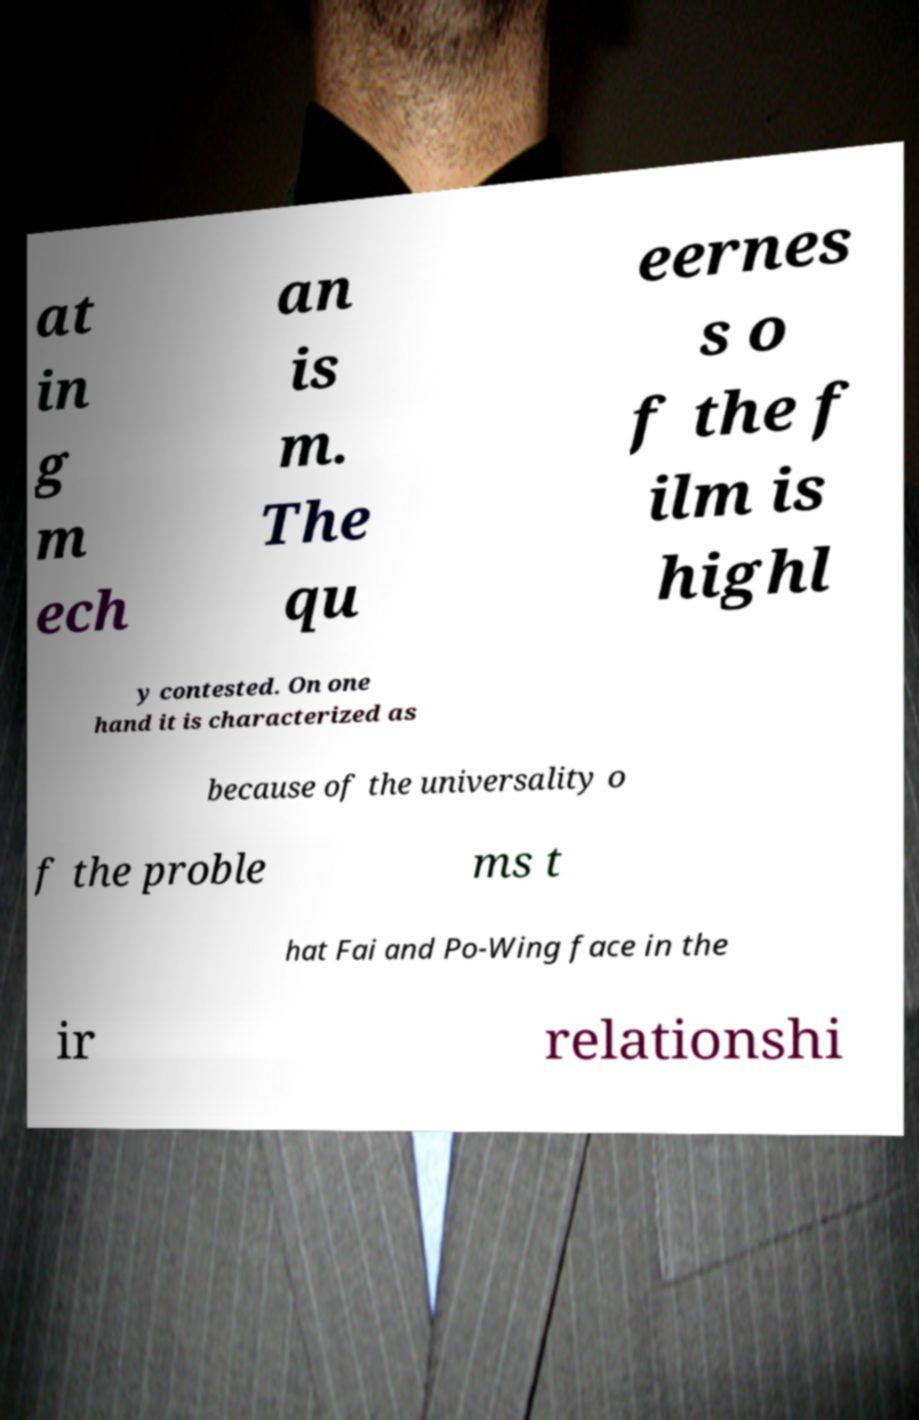For documentation purposes, I need the text within this image transcribed. Could you provide that? at in g m ech an is m. The qu eernes s o f the f ilm is highl y contested. On one hand it is characterized as because of the universality o f the proble ms t hat Fai and Po-Wing face in the ir relationshi 